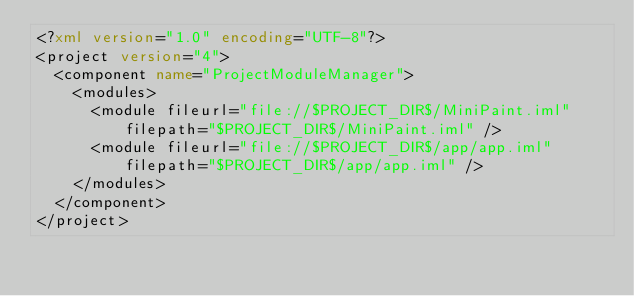<code> <loc_0><loc_0><loc_500><loc_500><_XML_><?xml version="1.0" encoding="UTF-8"?>
<project version="4">
  <component name="ProjectModuleManager">
    <modules>
      <module fileurl="file://$PROJECT_DIR$/MiniPaint.iml" filepath="$PROJECT_DIR$/MiniPaint.iml" />
      <module fileurl="file://$PROJECT_DIR$/app/app.iml" filepath="$PROJECT_DIR$/app/app.iml" />
    </modules>
  </component>
</project></code> 